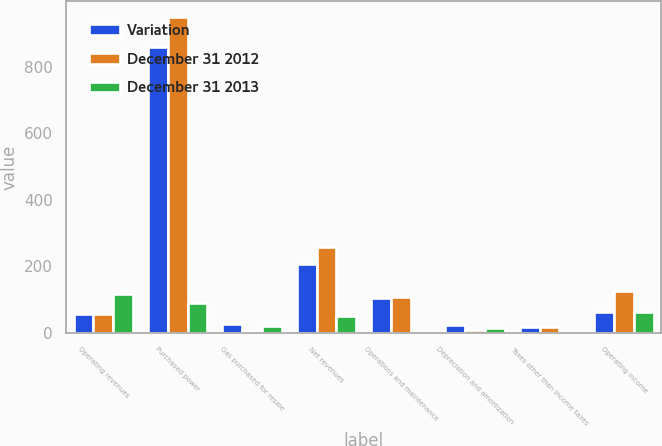Convert chart to OTSL. <chart><loc_0><loc_0><loc_500><loc_500><stacked_bar_chart><ecel><fcel>Operating revenues<fcel>Purchased power<fcel>Gas purchased for resale<fcel>Net revenues<fcel>Operations and maintenance<fcel>Depreciation and amortization<fcel>Taxes other than income taxes<fcel>Operating income<nl><fcel>Variation<fcel>56<fcel>861<fcel>27<fcel>208<fcel>105<fcel>23<fcel>17<fcel>63<nl><fcel>December 31 2012<fcel>56<fcel>950<fcel>5<fcel>258<fcel>107<fcel>8<fcel>18<fcel>125<nl><fcel>December 31 2013<fcel>117<fcel>89<fcel>22<fcel>50<fcel>2<fcel>15<fcel>1<fcel>62<nl></chart> 